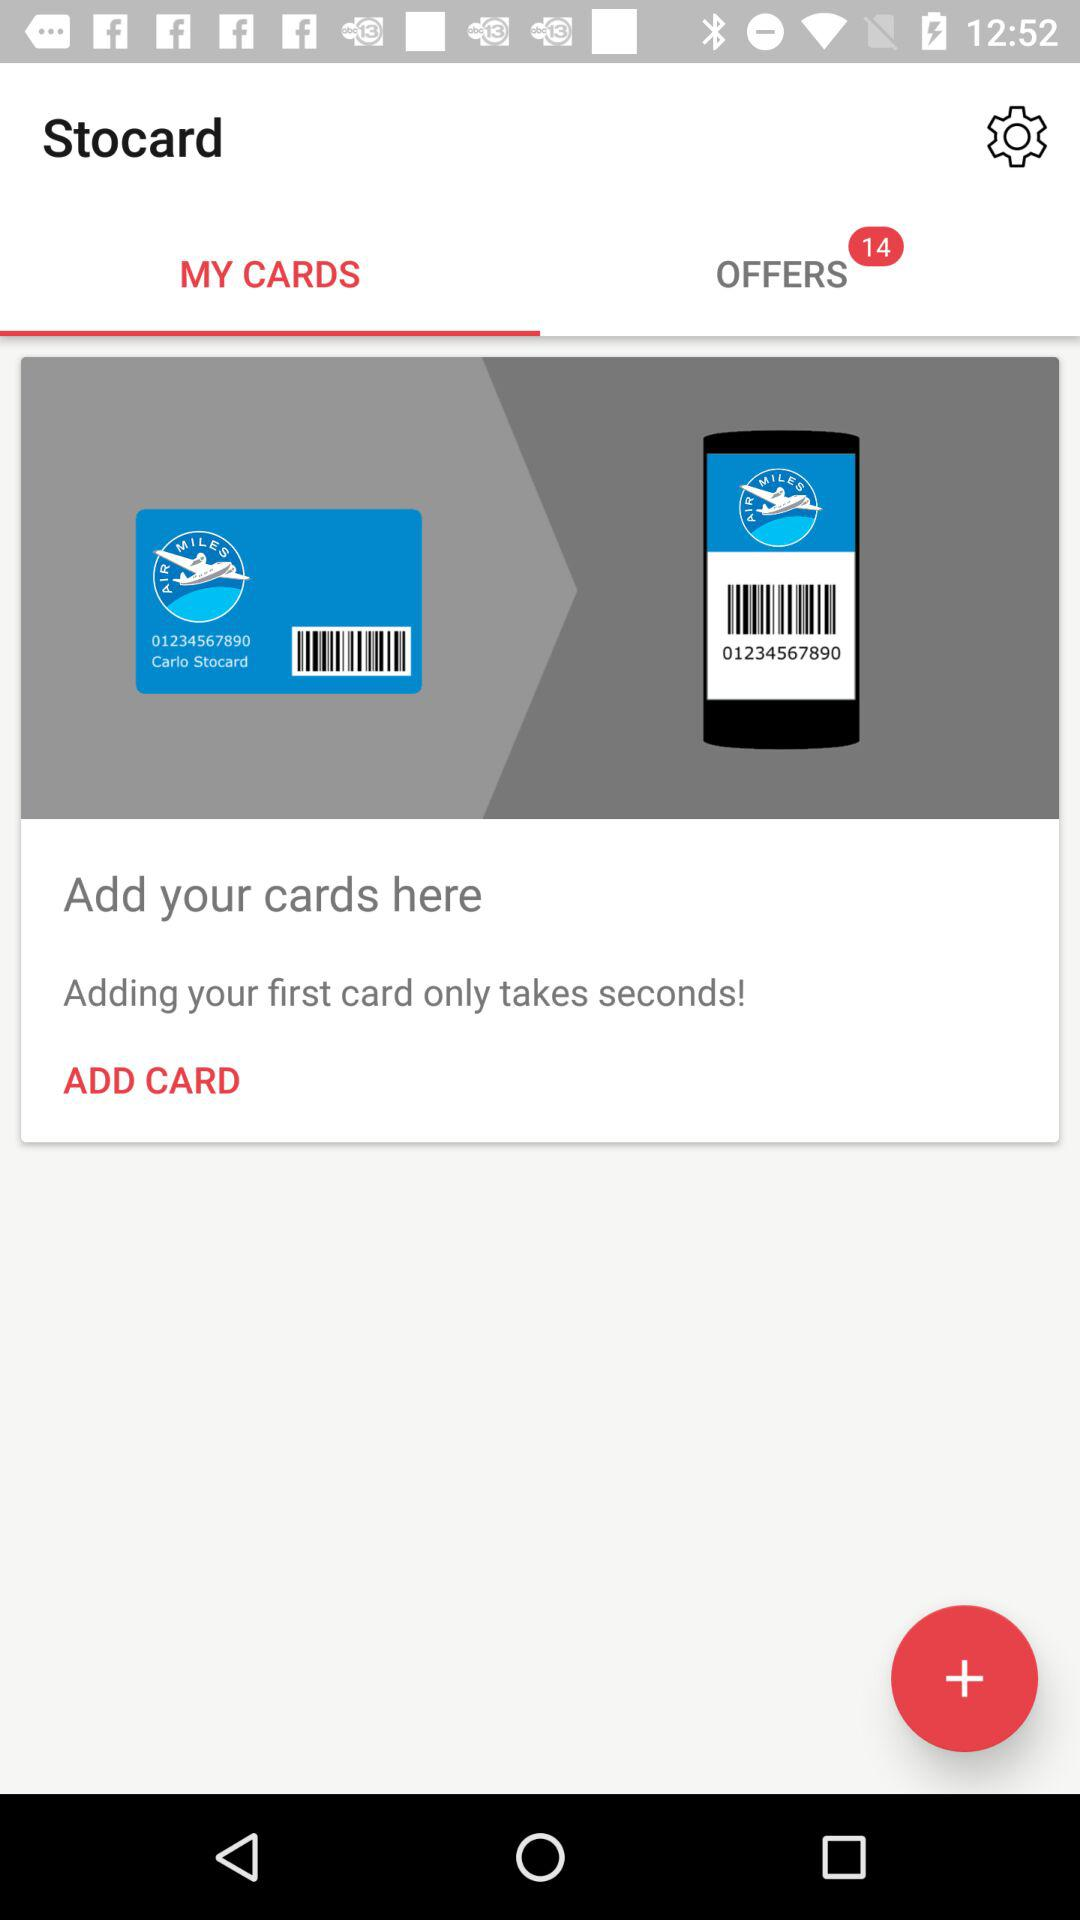Which tab has been selected? The tab that has been selected is "MY CARDS". 